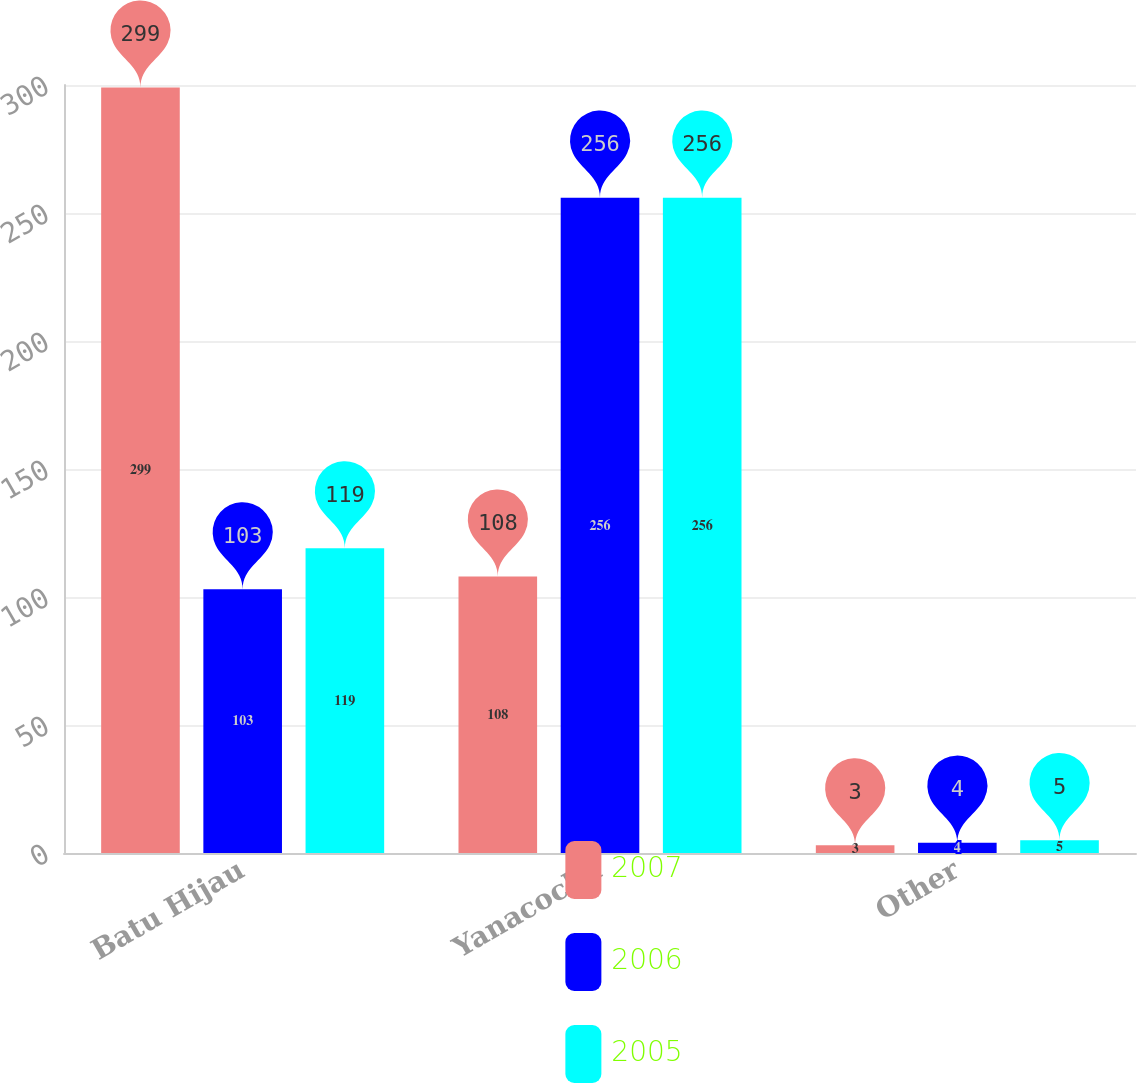Convert chart. <chart><loc_0><loc_0><loc_500><loc_500><stacked_bar_chart><ecel><fcel>Batu Hijau<fcel>Yanacocha<fcel>Other<nl><fcel>2007<fcel>299<fcel>108<fcel>3<nl><fcel>2006<fcel>103<fcel>256<fcel>4<nl><fcel>2005<fcel>119<fcel>256<fcel>5<nl></chart> 